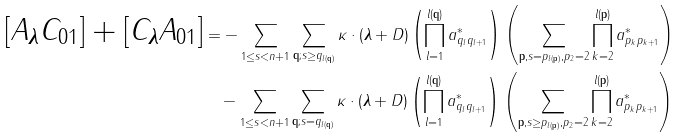Convert formula to latex. <formula><loc_0><loc_0><loc_500><loc_500>[ A _ { \boldsymbol \lambda } C _ { 0 1 } ] + [ C _ { \boldsymbol \lambda } A _ { 0 1 } ] & = - \sum _ { 1 \leq s < n + 1 } \sum _ { \mathbf q ; s \geq q _ { l ( \mathbf q ) } } \kappa \cdot ( { \boldsymbol \lambda } + D ) \left ( \prod _ { l = 1 } ^ { l ( \mathbf q ) } a _ { q _ { l } q _ { l + 1 } } ^ { * } \right ) \left ( \sum _ { \mathbf p , s = p _ { l ( \mathbf p ) } , p _ { 2 } = 2 } \prod _ { k = 2 } ^ { l ( \mathbf p ) } a _ { p _ { k } p { _ { k + 1 } } } ^ { * } \right ) \\ & \quad - \sum _ { 1 \leq s < n + 1 } \sum _ { \mathbf q ; s = q _ { l ( \mathbf q ) } } \kappa \cdot ( { \boldsymbol \lambda } + D ) \left ( \prod _ { l = 1 } ^ { l ( \mathbf q ) } a _ { q _ { l } q _ { l + 1 } } ^ { * } \right ) \left ( \sum _ { \mathbf p , s \geq p _ { l ( \mathbf p ) } , p _ { 2 } = 2 } \prod _ { k = 2 } ^ { l ( \mathbf p ) } a _ { p _ { k } p { _ { k + 1 } } } ^ { * } \right ) \\</formula> 